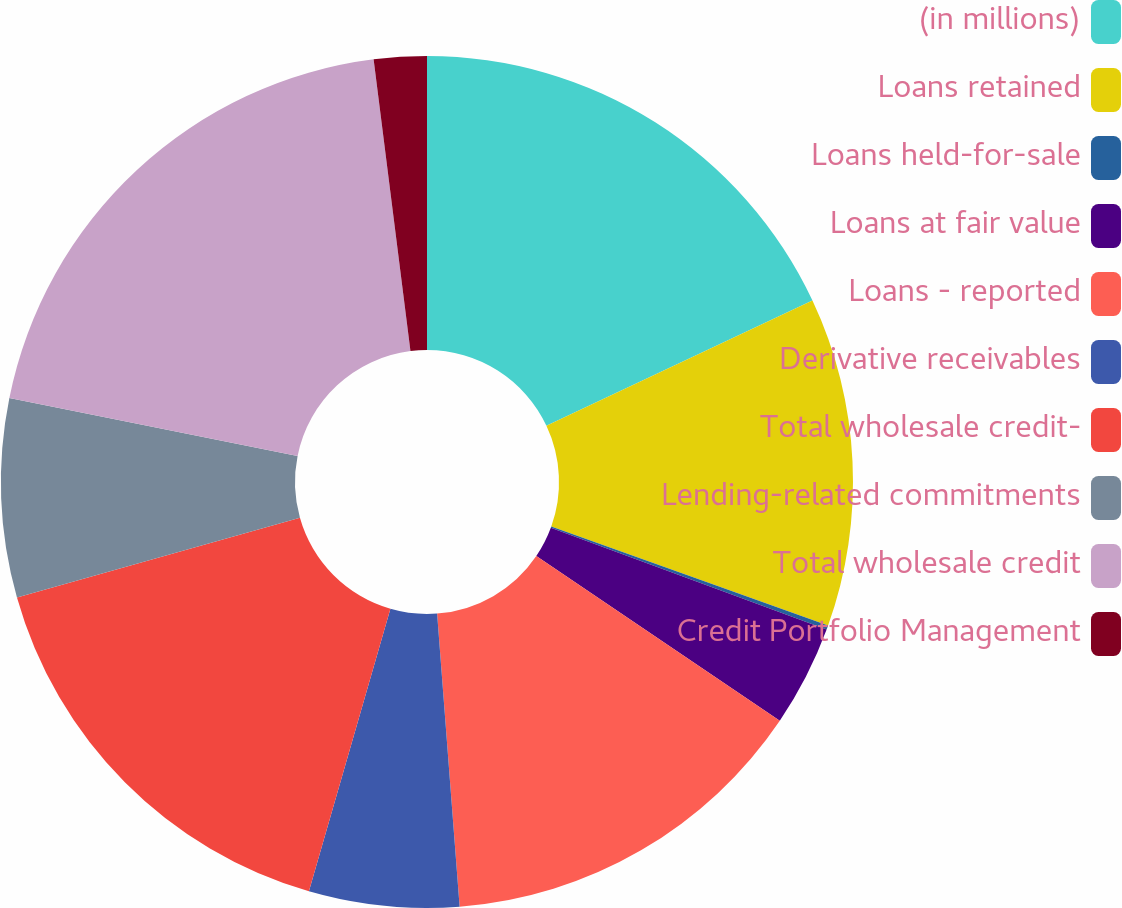<chart> <loc_0><loc_0><loc_500><loc_500><pie_chart><fcel>(in millions)<fcel>Loans retained<fcel>Loans held-for-sale<fcel>Loans at fair value<fcel>Loans - reported<fcel>Derivative receivables<fcel>Total wholesale credit-<fcel>Lending-related commitments<fcel>Total wholesale credit<fcel>Credit Portfolio Management<nl><fcel>18.0%<fcel>12.47%<fcel>0.16%<fcel>3.84%<fcel>14.31%<fcel>5.69%<fcel>16.16%<fcel>7.53%<fcel>19.84%<fcel>2.0%<nl></chart> 